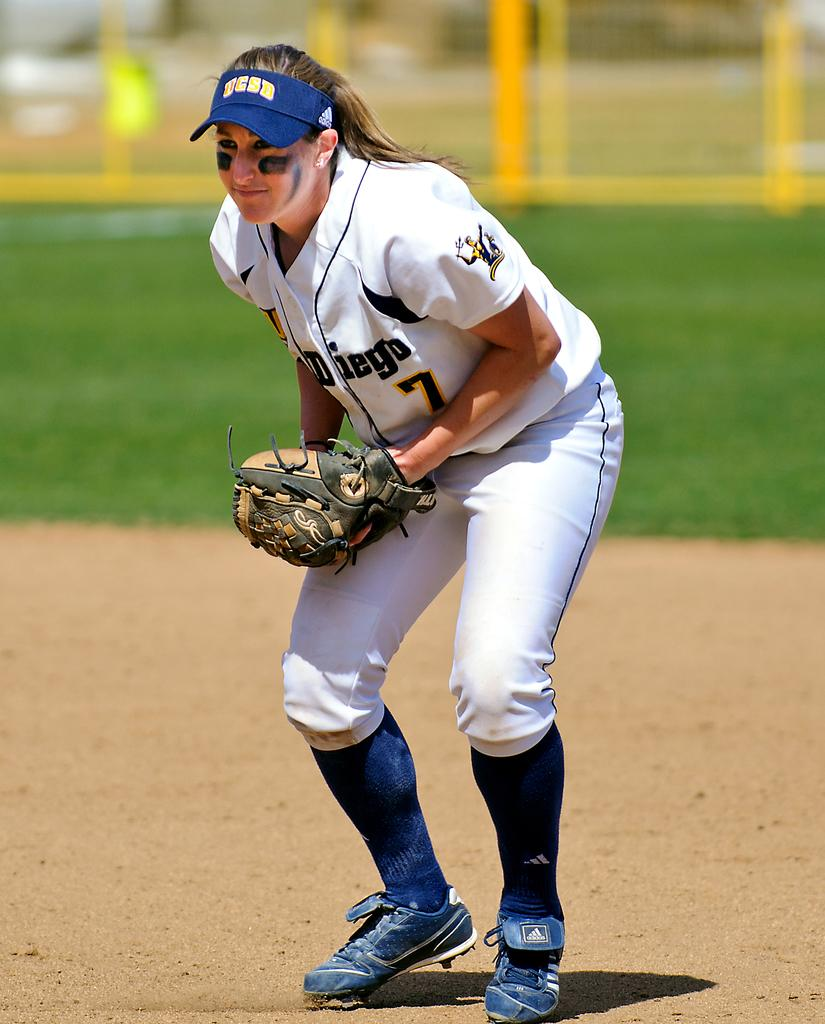Who is the main subject in the image? There is a woman in the image. What is the woman's position in the image? The woman is on the ground. What type of natural environment is visible in the background of the image? There is grass in the background of the image. What architectural feature can be seen in the background of the image? There is fencing in the background of the image. How would you describe the background of the image? The background of the image is blurred. What type of straw is the woman using to create harmony in the image? There is no straw or any indication of creating harmony present in the image. 